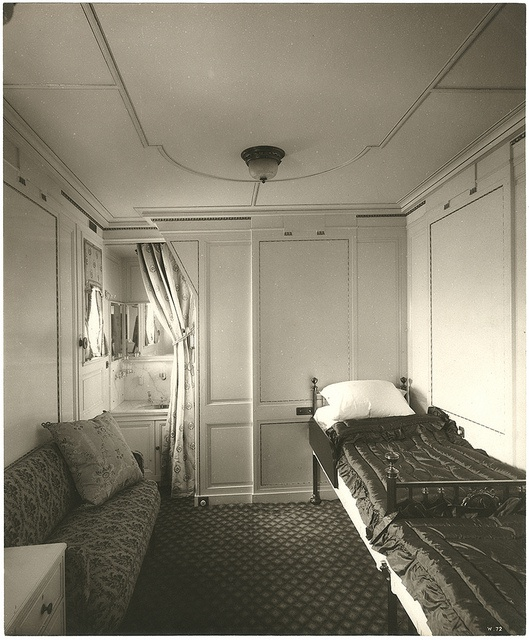Describe the objects in this image and their specific colors. I can see bed in white, black, gray, and ivory tones and couch in white, black, and gray tones in this image. 